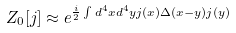Convert formula to latex. <formula><loc_0><loc_0><loc_500><loc_500>Z _ { 0 } [ j ] \approx e ^ { \frac { i } { 2 } \int d ^ { 4 } x d ^ { 4 } y j ( x ) \Delta ( x - y ) j ( y ) }</formula> 